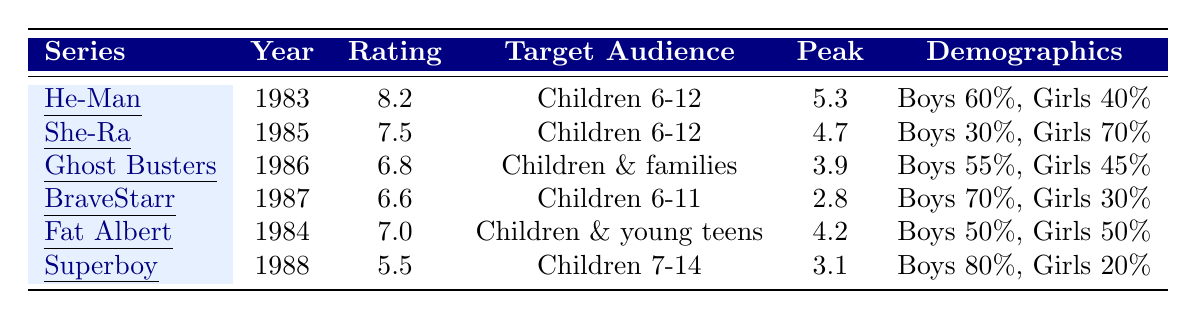What is the average rating of all Filmation series listed? To find the average rating, sum all ratings: 8.2 + 7.5 + 6.8 + 6.6 + 7.0 + 5.5 = 41.6. Then, divide by the number of series, which is 6. Therefore, 41.6 / 6 = 6.9333, which rounds to 6.9.
Answer: 6.9 Which series had the highest peak viewership? The peak viewership data shows He-Man had a peak of 5.3, which is higher than all other series' peak viewership.
Answer: He-Man and the Masters of the Universe What percentage of viewers for She-Ra were girls? The demographic breakdown for She-Ra indicates girls accounted for 70% of the viewership.
Answer: 70% Did BraveStarr have a higher average rating than The Adventures of Superboy? BraveStarr's average rating is 6.6 while The Adventures of Superboy has a rating of 5.5. Since 6.6 is greater than 5.5, the statement is true.
Answer: Yes What is the combined average viewership peak of Fat Albert and The Ghost Busters? First, identify the peak viewership: Fat Albert's peak is 4.2 and Ghost Busters' is 3.9. Add them together: 4.2 + 3.9 = 8.1. Then, divide by 2 to find the average: 8.1 / 2 = 4.05.
Answer: 4.05 Which series is targeted at an older audience than the others? The target audiences show that The Adventures of Superboy is for children aged 7-14, while all others are generally for ages up to 12. This makes Superboy targeted at an older audience.
Answer: The Adventures of Superboy Which series had the lowest average rating? By examining the average ratings in the table, The Adventures of Superboy has the lowest rating at 5.5.
Answer: The Adventures of Superboy What was the gender distribution for viewership of He-Man? The demographic breakdown for He-Man shows boys made up 60% and girls made up 40% of the viewers.
Answer: Boys 60%, Girls 40% Was She-Ra more popular among boys or girls? The demographic for She-Ra indicates that 30% of viewers were boys, while 70% were girls, indicating it was more popular among girls.
Answer: Girls If you combine the ratings of Fat Albert and She-Ra, what is the total? Fat Albert has a rating of 7.0 and She-Ra has a rating of 7.5. Add them together: 7.0 + 7.5 = 14.5.
Answer: 14.5 Which series had the smallest percentage of female viewership? By looking at the demographics, BraveStarr had 30% female viewers, which is the smallest percentage among the series listed.
Answer: BraveStarr 